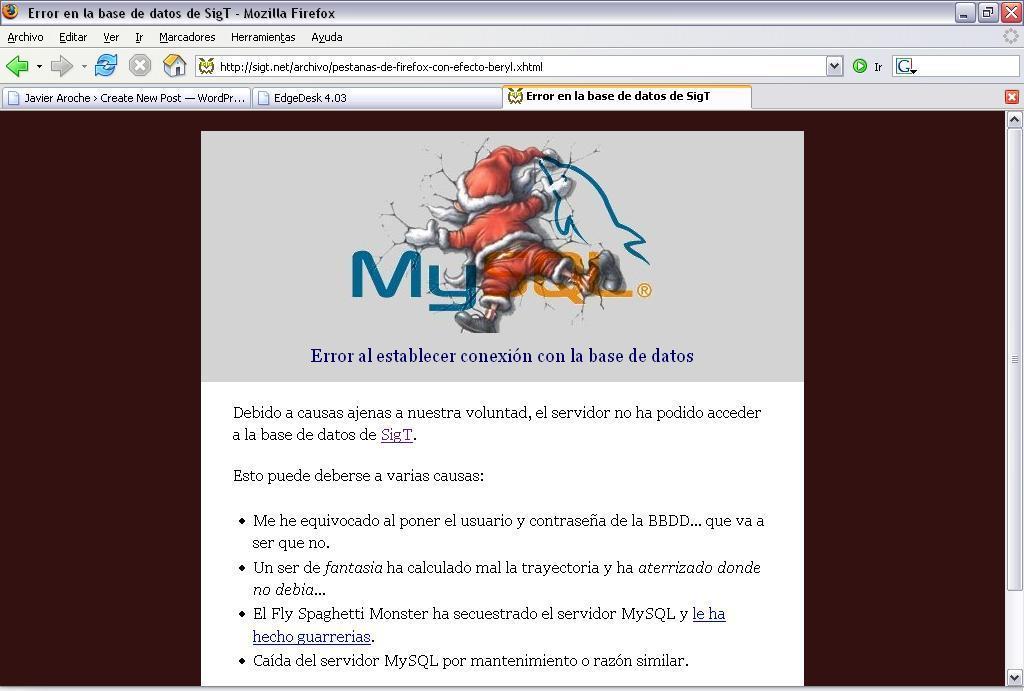Can you describe this image briefly? In this image I can see screenshot of the screen. Top I can see few icons. I can see red color santa-claus and something is written on it. 